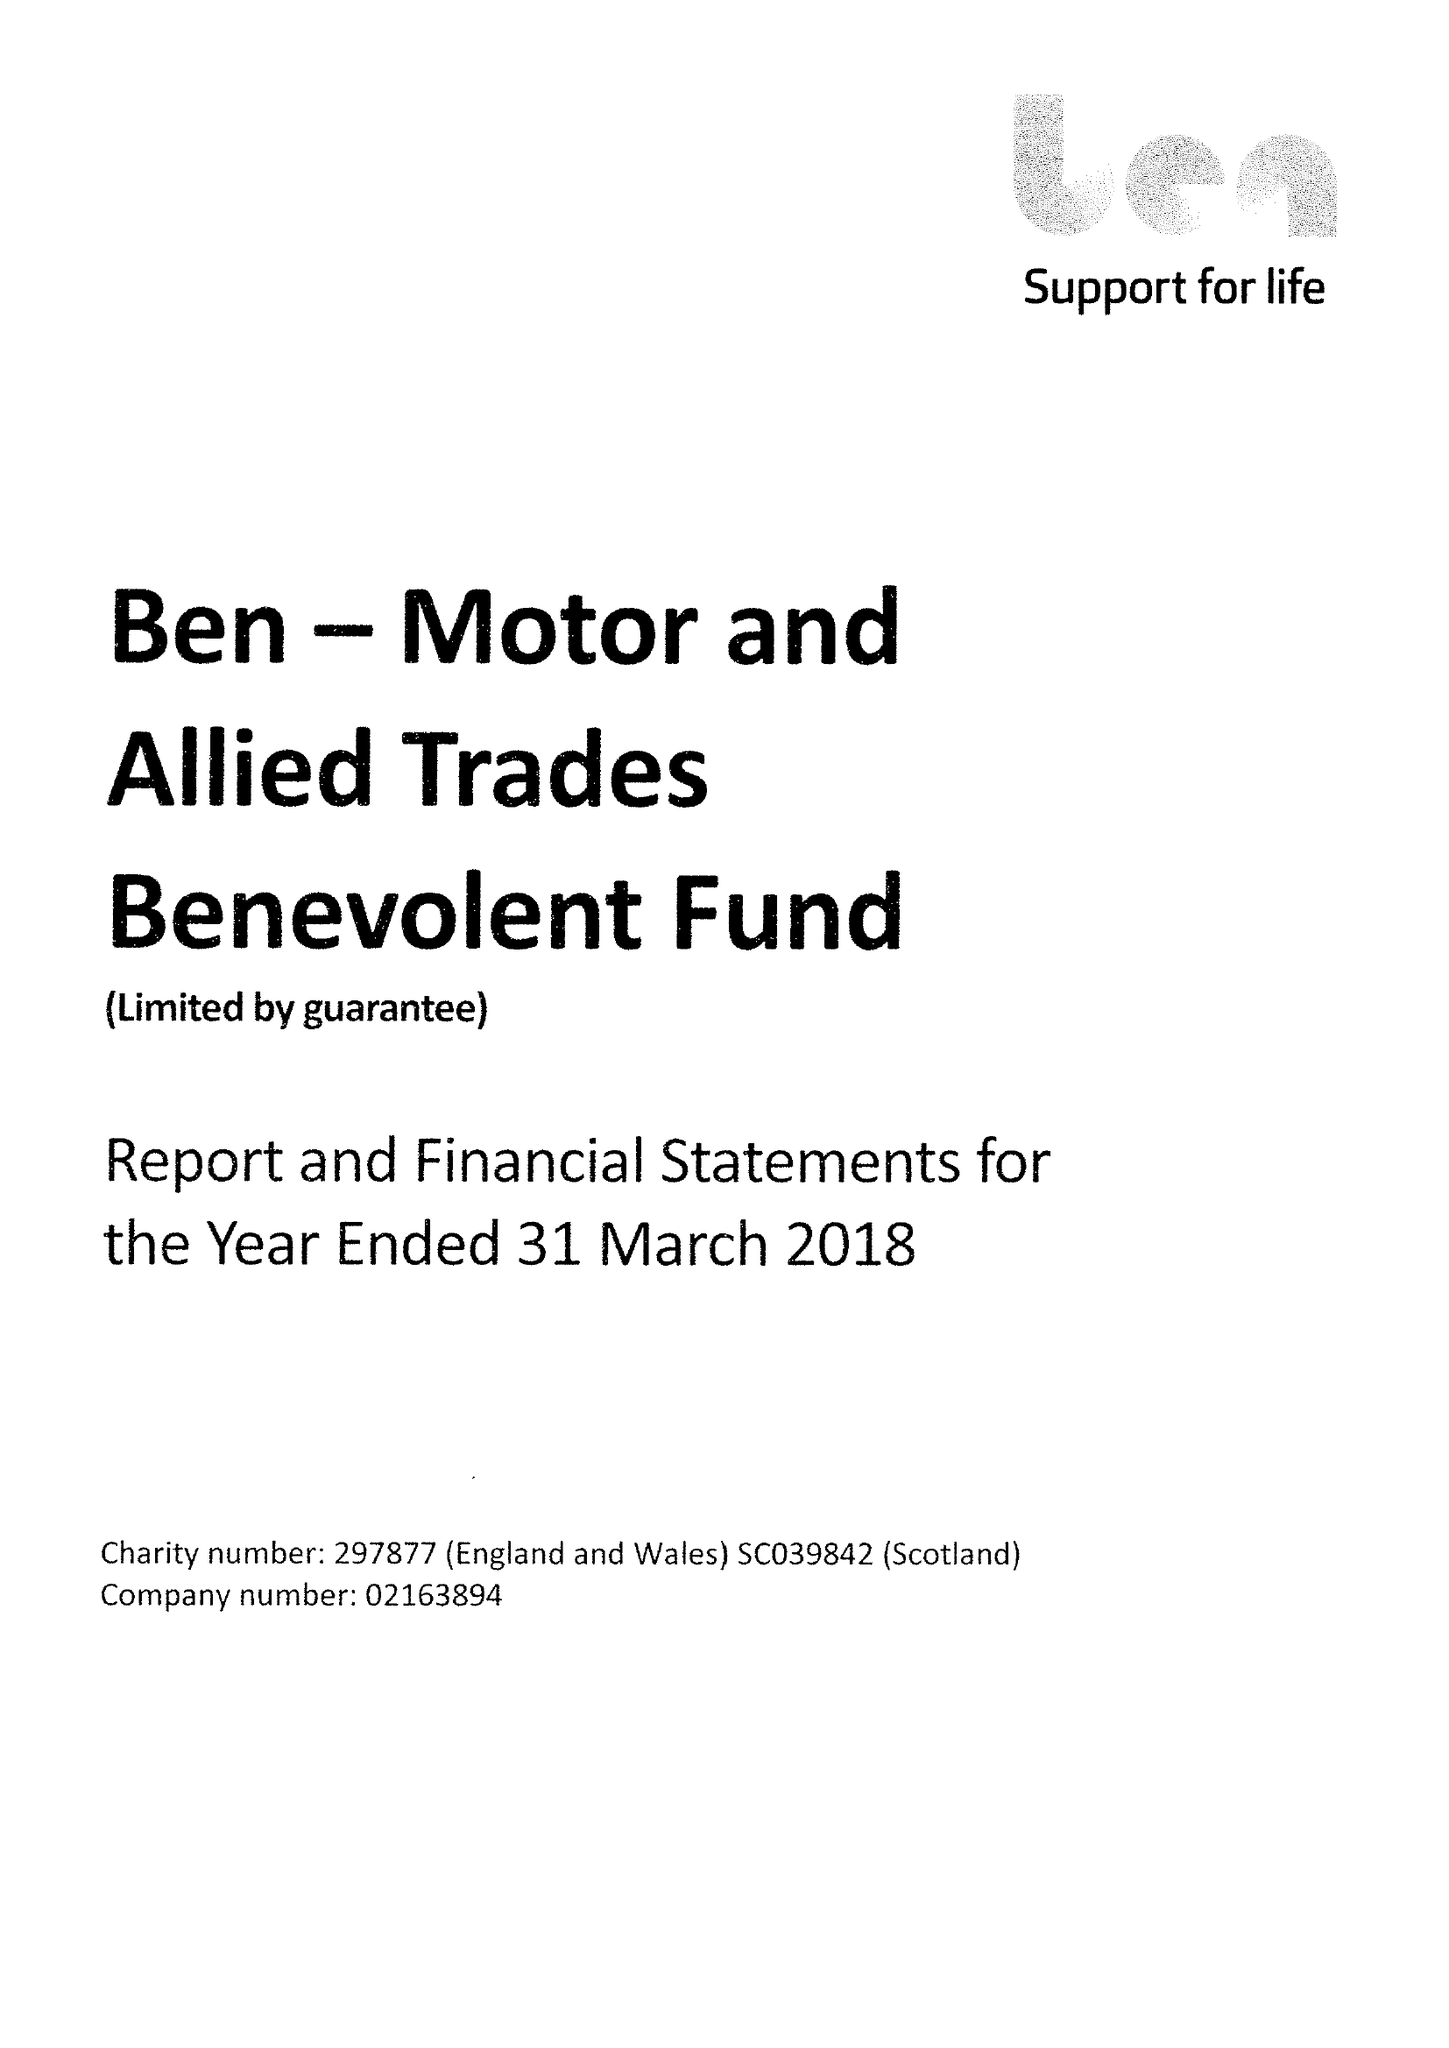What is the value for the charity_number?
Answer the question using a single word or phrase. 297877 